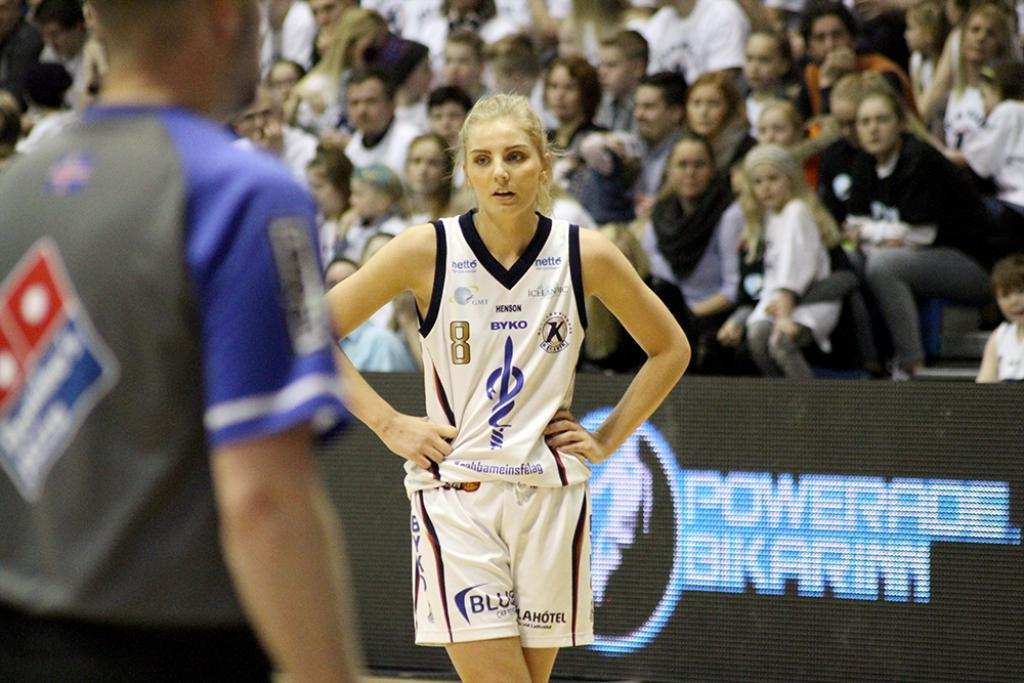<image>
Offer a succinct explanation of the picture presented. A female basketball player is standing with her hands on her hips at a game in the Powerade stadium. 